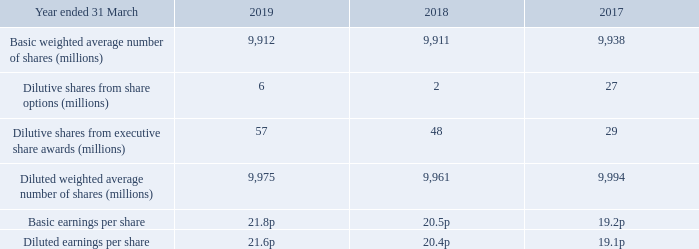12. Earnings per share How are earnings per share calculated?
Basic earnings per share is calculated by dividing the profit after tax attributable to equity shareholders by the weighted average number of shares in issue after deducting the own shares held by employee share ownership trusts and treasury shares.
In calculating the diluted earnings per share, share options outstanding and other potential shares have been taken into account where the impact of these is dilutive. Options over 36m shares (2017/18: 23m shares, 2016/17: 27m shares) were excluded from the calculation of the total diluted number of shares as the impact of these is antidilutive.
The earnings per share calculations are based on profit after tax attributable to equity shareholders of the parent company which excludes non-controlling interests. Profit after tax was £2,159m (2017/18: £2,032m, 2016/17: £1,908m) and profit after tax attributable to non-controlling interests was £3m (2017/18: £4m, 2016/17: £1m). Profit attributable to non-controlling interests is not presented separately in the financial statements as it is not material.
How is basic earnings per share calculated? Calculated by dividing the profit after tax attributable to equity shareholders by the weighted average number of shares in issue after deducting the own shares held by employee share ownership trusts and treasury shares. What was the option amount which was excluded from the calculation of total diluted number of shares in 2019? 36m shares. What was the  Basic weighted average number of shares (millions)  in 2019?
Answer scale should be: million. 9,912. What was the change in the Basic weighted average number of shares (millions) from 2018 to 2019?
Answer scale should be: million. 9,912 - 9,911
Answer: 1. What is the average Dilutive shares from share options (millions) in 2017-2019?
Answer scale should be: million. (6 + 2 + 27) / 3
Answer: 11.67. What is the percentage change in the Dilutive shares from executive share awards (millions) from 2018 to 2019?
Answer scale should be: percent. 57 / 48 - 1
Answer: 18.75. 